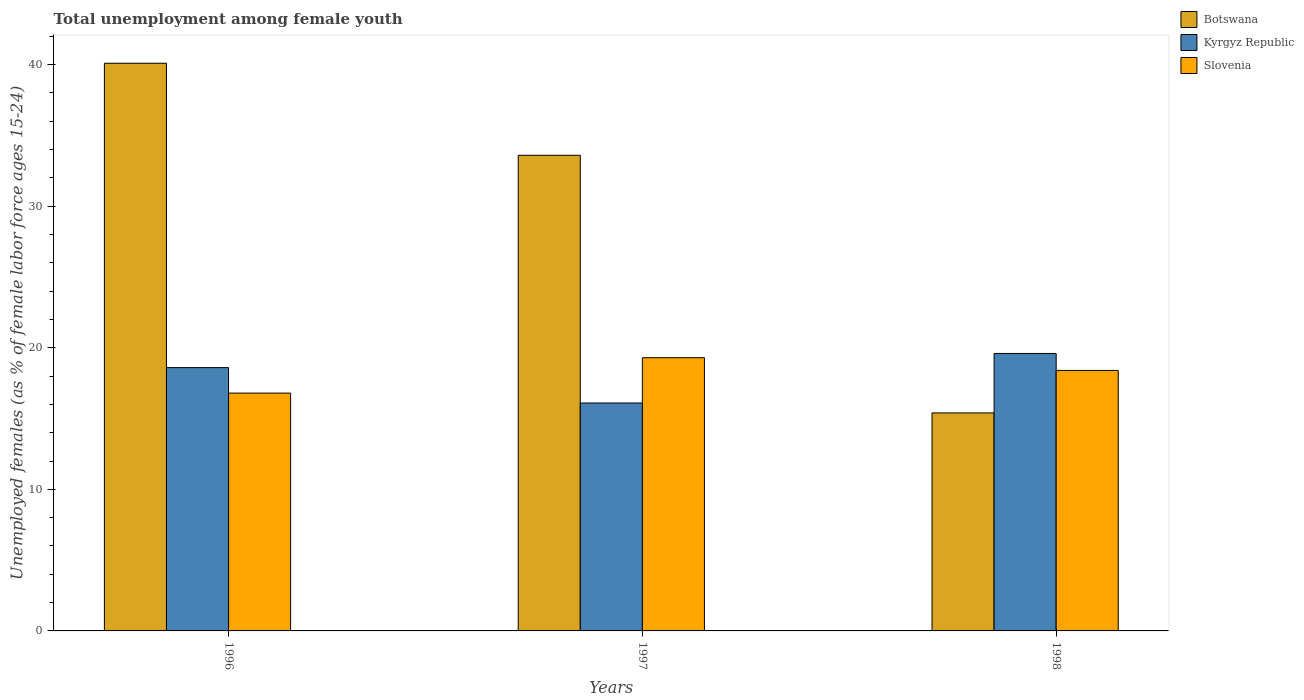How many groups of bars are there?
Ensure brevity in your answer.  3. Are the number of bars per tick equal to the number of legend labels?
Your response must be concise. Yes. What is the label of the 2nd group of bars from the left?
Your answer should be very brief. 1997. What is the percentage of unemployed females in in Kyrgyz Republic in 1998?
Your answer should be very brief. 19.6. Across all years, what is the maximum percentage of unemployed females in in Slovenia?
Make the answer very short. 19.3. Across all years, what is the minimum percentage of unemployed females in in Slovenia?
Offer a very short reply. 16.8. In which year was the percentage of unemployed females in in Kyrgyz Republic maximum?
Keep it short and to the point. 1998. In which year was the percentage of unemployed females in in Botswana minimum?
Keep it short and to the point. 1998. What is the total percentage of unemployed females in in Botswana in the graph?
Provide a short and direct response. 89.1. What is the difference between the percentage of unemployed females in in Slovenia in 1998 and the percentage of unemployed females in in Kyrgyz Republic in 1996?
Your response must be concise. -0.2. What is the average percentage of unemployed females in in Kyrgyz Republic per year?
Give a very brief answer. 18.1. In the year 1996, what is the difference between the percentage of unemployed females in in Slovenia and percentage of unemployed females in in Botswana?
Ensure brevity in your answer.  -23.3. In how many years, is the percentage of unemployed females in in Botswana greater than 18 %?
Your answer should be very brief. 2. What is the ratio of the percentage of unemployed females in in Slovenia in 1996 to that in 1997?
Provide a succinct answer. 0.87. Is the percentage of unemployed females in in Botswana in 1996 less than that in 1997?
Offer a very short reply. No. What is the difference between the highest and the second highest percentage of unemployed females in in Slovenia?
Ensure brevity in your answer.  0.9. In how many years, is the percentage of unemployed females in in Slovenia greater than the average percentage of unemployed females in in Slovenia taken over all years?
Your answer should be very brief. 2. Is the sum of the percentage of unemployed females in in Slovenia in 1996 and 1998 greater than the maximum percentage of unemployed females in in Kyrgyz Republic across all years?
Offer a terse response. Yes. What does the 2nd bar from the left in 1998 represents?
Ensure brevity in your answer.  Kyrgyz Republic. What does the 3rd bar from the right in 1996 represents?
Your answer should be very brief. Botswana. Are all the bars in the graph horizontal?
Provide a short and direct response. No. What is the difference between two consecutive major ticks on the Y-axis?
Your answer should be compact. 10. Are the values on the major ticks of Y-axis written in scientific E-notation?
Provide a short and direct response. No. Does the graph contain grids?
Make the answer very short. No. What is the title of the graph?
Make the answer very short. Total unemployment among female youth. Does "China" appear as one of the legend labels in the graph?
Your response must be concise. No. What is the label or title of the X-axis?
Make the answer very short. Years. What is the label or title of the Y-axis?
Make the answer very short. Unemployed females (as % of female labor force ages 15-24). What is the Unemployed females (as % of female labor force ages 15-24) in Botswana in 1996?
Your answer should be compact. 40.1. What is the Unemployed females (as % of female labor force ages 15-24) in Kyrgyz Republic in 1996?
Keep it short and to the point. 18.6. What is the Unemployed females (as % of female labor force ages 15-24) of Slovenia in 1996?
Ensure brevity in your answer.  16.8. What is the Unemployed females (as % of female labor force ages 15-24) of Botswana in 1997?
Provide a short and direct response. 33.6. What is the Unemployed females (as % of female labor force ages 15-24) of Kyrgyz Republic in 1997?
Provide a short and direct response. 16.1. What is the Unemployed females (as % of female labor force ages 15-24) in Slovenia in 1997?
Give a very brief answer. 19.3. What is the Unemployed females (as % of female labor force ages 15-24) of Botswana in 1998?
Offer a terse response. 15.4. What is the Unemployed females (as % of female labor force ages 15-24) in Kyrgyz Republic in 1998?
Offer a terse response. 19.6. What is the Unemployed females (as % of female labor force ages 15-24) in Slovenia in 1998?
Provide a short and direct response. 18.4. Across all years, what is the maximum Unemployed females (as % of female labor force ages 15-24) in Botswana?
Make the answer very short. 40.1. Across all years, what is the maximum Unemployed females (as % of female labor force ages 15-24) in Kyrgyz Republic?
Keep it short and to the point. 19.6. Across all years, what is the maximum Unemployed females (as % of female labor force ages 15-24) of Slovenia?
Provide a succinct answer. 19.3. Across all years, what is the minimum Unemployed females (as % of female labor force ages 15-24) in Botswana?
Provide a succinct answer. 15.4. Across all years, what is the minimum Unemployed females (as % of female labor force ages 15-24) in Kyrgyz Republic?
Keep it short and to the point. 16.1. Across all years, what is the minimum Unemployed females (as % of female labor force ages 15-24) in Slovenia?
Offer a very short reply. 16.8. What is the total Unemployed females (as % of female labor force ages 15-24) in Botswana in the graph?
Your response must be concise. 89.1. What is the total Unemployed females (as % of female labor force ages 15-24) of Kyrgyz Republic in the graph?
Your answer should be compact. 54.3. What is the total Unemployed females (as % of female labor force ages 15-24) in Slovenia in the graph?
Make the answer very short. 54.5. What is the difference between the Unemployed females (as % of female labor force ages 15-24) of Botswana in 1996 and that in 1997?
Your answer should be very brief. 6.5. What is the difference between the Unemployed females (as % of female labor force ages 15-24) of Slovenia in 1996 and that in 1997?
Make the answer very short. -2.5. What is the difference between the Unemployed females (as % of female labor force ages 15-24) in Botswana in 1996 and that in 1998?
Keep it short and to the point. 24.7. What is the difference between the Unemployed females (as % of female labor force ages 15-24) of Kyrgyz Republic in 1997 and that in 1998?
Your response must be concise. -3.5. What is the difference between the Unemployed females (as % of female labor force ages 15-24) in Slovenia in 1997 and that in 1998?
Provide a succinct answer. 0.9. What is the difference between the Unemployed females (as % of female labor force ages 15-24) in Botswana in 1996 and the Unemployed females (as % of female labor force ages 15-24) in Slovenia in 1997?
Provide a succinct answer. 20.8. What is the difference between the Unemployed females (as % of female labor force ages 15-24) in Kyrgyz Republic in 1996 and the Unemployed females (as % of female labor force ages 15-24) in Slovenia in 1997?
Offer a terse response. -0.7. What is the difference between the Unemployed females (as % of female labor force ages 15-24) of Botswana in 1996 and the Unemployed females (as % of female labor force ages 15-24) of Kyrgyz Republic in 1998?
Ensure brevity in your answer.  20.5. What is the difference between the Unemployed females (as % of female labor force ages 15-24) in Botswana in 1996 and the Unemployed females (as % of female labor force ages 15-24) in Slovenia in 1998?
Your answer should be very brief. 21.7. What is the difference between the Unemployed females (as % of female labor force ages 15-24) in Botswana in 1997 and the Unemployed females (as % of female labor force ages 15-24) in Kyrgyz Republic in 1998?
Ensure brevity in your answer.  14. What is the average Unemployed females (as % of female labor force ages 15-24) of Botswana per year?
Give a very brief answer. 29.7. What is the average Unemployed females (as % of female labor force ages 15-24) in Slovenia per year?
Ensure brevity in your answer.  18.17. In the year 1996, what is the difference between the Unemployed females (as % of female labor force ages 15-24) of Botswana and Unemployed females (as % of female labor force ages 15-24) of Kyrgyz Republic?
Give a very brief answer. 21.5. In the year 1996, what is the difference between the Unemployed females (as % of female labor force ages 15-24) of Botswana and Unemployed females (as % of female labor force ages 15-24) of Slovenia?
Provide a short and direct response. 23.3. In the year 1996, what is the difference between the Unemployed females (as % of female labor force ages 15-24) of Kyrgyz Republic and Unemployed females (as % of female labor force ages 15-24) of Slovenia?
Your answer should be compact. 1.8. In the year 1997, what is the difference between the Unemployed females (as % of female labor force ages 15-24) in Botswana and Unemployed females (as % of female labor force ages 15-24) in Kyrgyz Republic?
Make the answer very short. 17.5. In the year 1997, what is the difference between the Unemployed females (as % of female labor force ages 15-24) of Botswana and Unemployed females (as % of female labor force ages 15-24) of Slovenia?
Give a very brief answer. 14.3. In the year 1997, what is the difference between the Unemployed females (as % of female labor force ages 15-24) in Kyrgyz Republic and Unemployed females (as % of female labor force ages 15-24) in Slovenia?
Give a very brief answer. -3.2. In the year 1998, what is the difference between the Unemployed females (as % of female labor force ages 15-24) in Botswana and Unemployed females (as % of female labor force ages 15-24) in Kyrgyz Republic?
Your answer should be very brief. -4.2. In the year 1998, what is the difference between the Unemployed females (as % of female labor force ages 15-24) of Botswana and Unemployed females (as % of female labor force ages 15-24) of Slovenia?
Ensure brevity in your answer.  -3. What is the ratio of the Unemployed females (as % of female labor force ages 15-24) in Botswana in 1996 to that in 1997?
Offer a very short reply. 1.19. What is the ratio of the Unemployed females (as % of female labor force ages 15-24) in Kyrgyz Republic in 1996 to that in 1997?
Give a very brief answer. 1.16. What is the ratio of the Unemployed females (as % of female labor force ages 15-24) of Slovenia in 1996 to that in 1997?
Provide a short and direct response. 0.87. What is the ratio of the Unemployed females (as % of female labor force ages 15-24) of Botswana in 1996 to that in 1998?
Offer a terse response. 2.6. What is the ratio of the Unemployed females (as % of female labor force ages 15-24) of Kyrgyz Republic in 1996 to that in 1998?
Your response must be concise. 0.95. What is the ratio of the Unemployed females (as % of female labor force ages 15-24) in Botswana in 1997 to that in 1998?
Your response must be concise. 2.18. What is the ratio of the Unemployed females (as % of female labor force ages 15-24) of Kyrgyz Republic in 1997 to that in 1998?
Offer a terse response. 0.82. What is the ratio of the Unemployed females (as % of female labor force ages 15-24) in Slovenia in 1997 to that in 1998?
Ensure brevity in your answer.  1.05. What is the difference between the highest and the lowest Unemployed females (as % of female labor force ages 15-24) in Botswana?
Your answer should be compact. 24.7. What is the difference between the highest and the lowest Unemployed females (as % of female labor force ages 15-24) in Kyrgyz Republic?
Offer a terse response. 3.5. What is the difference between the highest and the lowest Unemployed females (as % of female labor force ages 15-24) in Slovenia?
Offer a terse response. 2.5. 